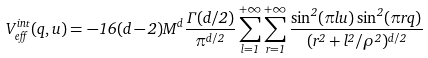<formula> <loc_0><loc_0><loc_500><loc_500>V _ { e f f } ^ { i n t } ( q , u ) = - 1 6 ( d - 2 ) M ^ { d } \frac { \Gamma ( d / 2 ) } { \pi ^ { d / 2 } } \sum _ { l = 1 } ^ { + \infty } \sum _ { r = 1 } ^ { + \infty } \frac { \sin ^ { 2 } ( \pi l u ) \sin ^ { 2 } ( \pi r q ) } { ( r ^ { 2 } + l ^ { 2 } / \rho ^ { 2 } ) ^ { d / 2 } }</formula> 